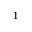Convert formula to latex. <formula><loc_0><loc_0><loc_500><loc_500>^ { 1 }</formula> 